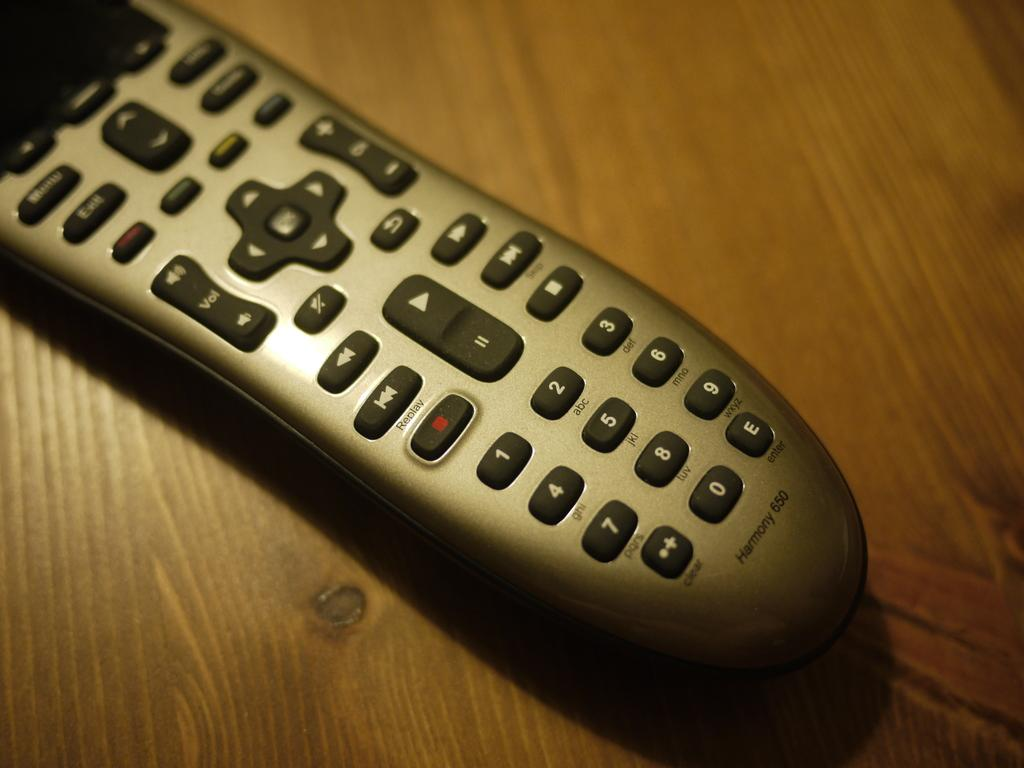<image>
Render a clear and concise summary of the photo. a harmony 650 silver and black remote control 